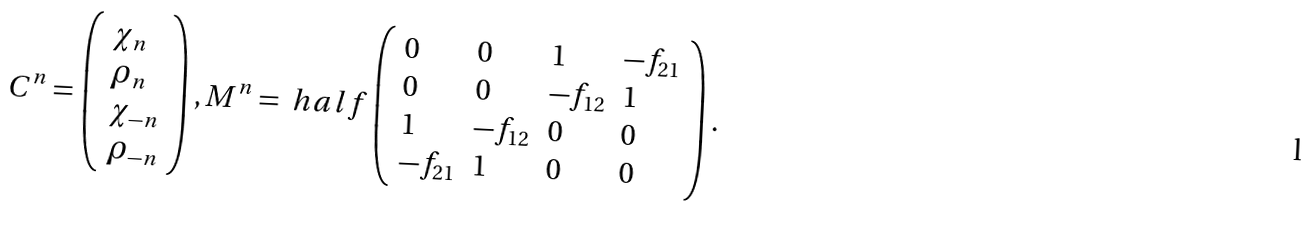<formula> <loc_0><loc_0><loc_500><loc_500>C ^ { n } = \left ( \begin{array} { l } \chi _ { n } \\ \rho _ { n } \\ \chi _ { - n } \\ \rho _ { - n } \\ \end{array} \right ) , M ^ { n } = \ h a l f \left ( \begin{array} { l l l l } 0 & 0 & 1 & - f _ { 2 1 } \\ 0 & 0 & - f _ { 1 2 } & 1 \\ 1 & - f _ { 1 2 } & 0 & 0 \\ - f _ { 2 1 } & 1 & 0 & 0 \\ \end{array} \right ) .</formula> 